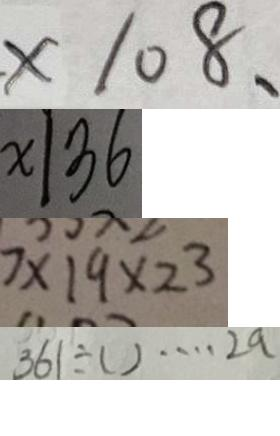<formula> <loc_0><loc_0><loc_500><loc_500>. \times 1 0 8 、 
 x \vert 3 6 
 7 \times 1 9 \times 2 ^ { 3 } 
 3 6 1 \div ( ) \cdots 2 a</formula> 